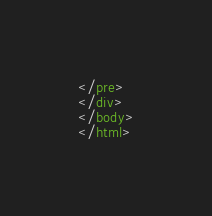Convert code to text. <code><loc_0><loc_0><loc_500><loc_500><_HTML_>
























</pre>
</div>
</body>
</html>
</code> 